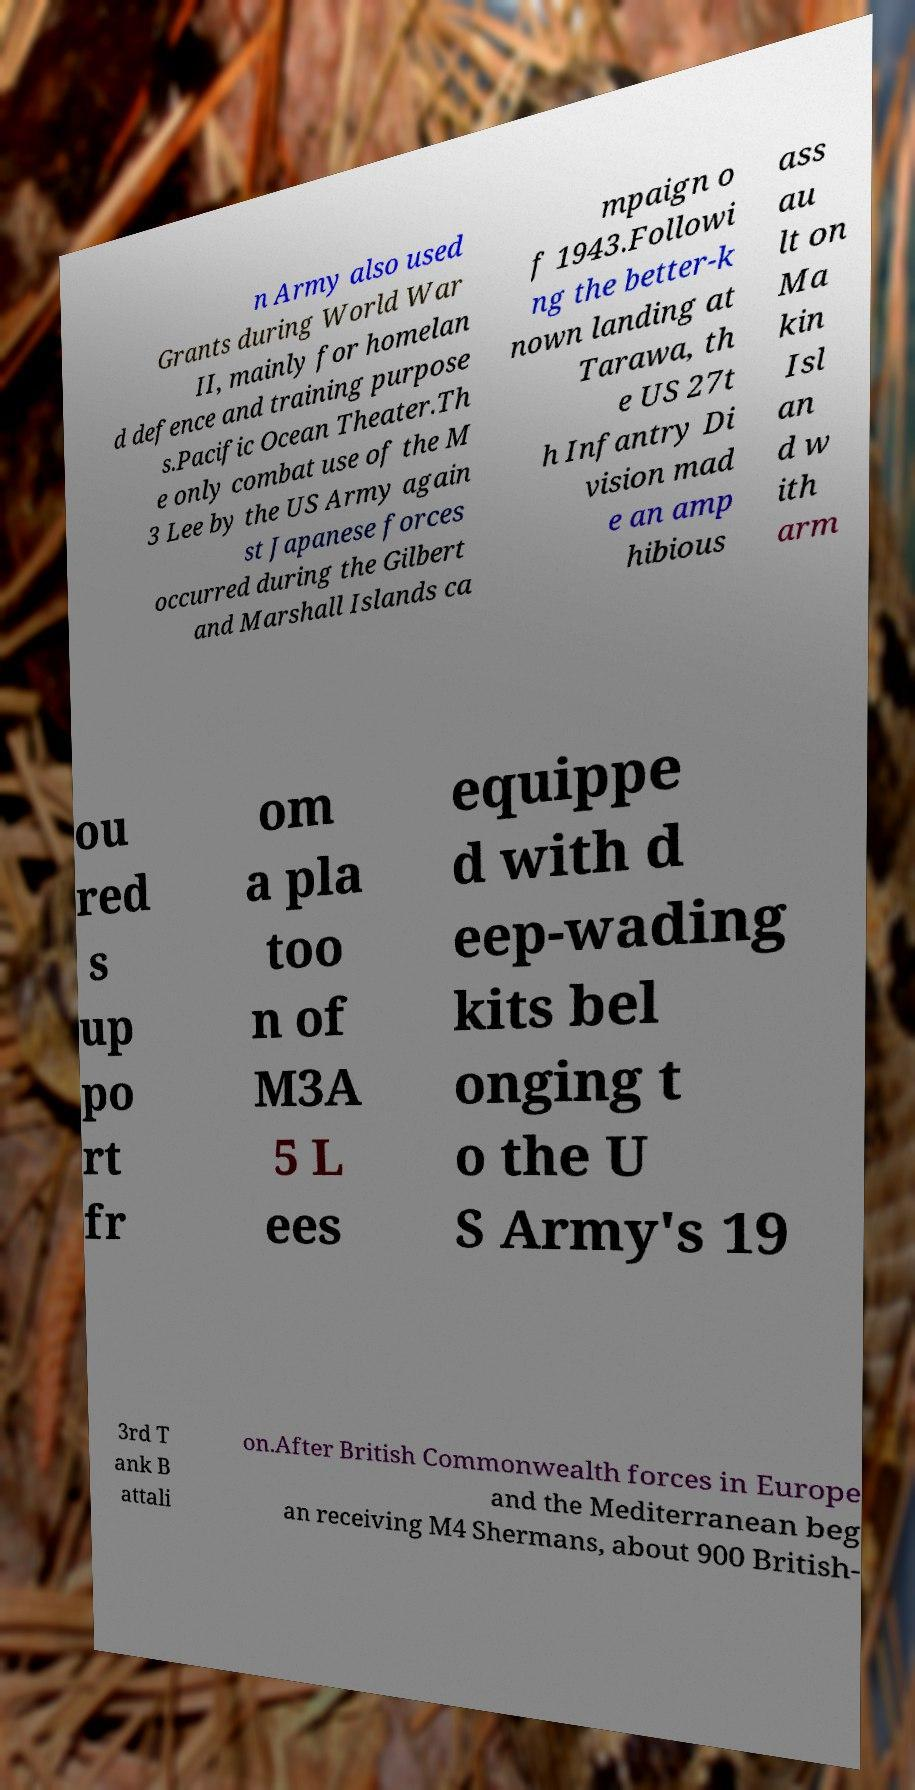Can you read and provide the text displayed in the image?This photo seems to have some interesting text. Can you extract and type it out for me? n Army also used Grants during World War II, mainly for homelan d defence and training purpose s.Pacific Ocean Theater.Th e only combat use of the M 3 Lee by the US Army again st Japanese forces occurred during the Gilbert and Marshall Islands ca mpaign o f 1943.Followi ng the better-k nown landing at Tarawa, th e US 27t h Infantry Di vision mad e an amp hibious ass au lt on Ma kin Isl an d w ith arm ou red s up po rt fr om a pla too n of M3A 5 L ees equippe d with d eep-wading kits bel onging t o the U S Army's 19 3rd T ank B attali on.After British Commonwealth forces in Europe and the Mediterranean beg an receiving M4 Shermans, about 900 British- 